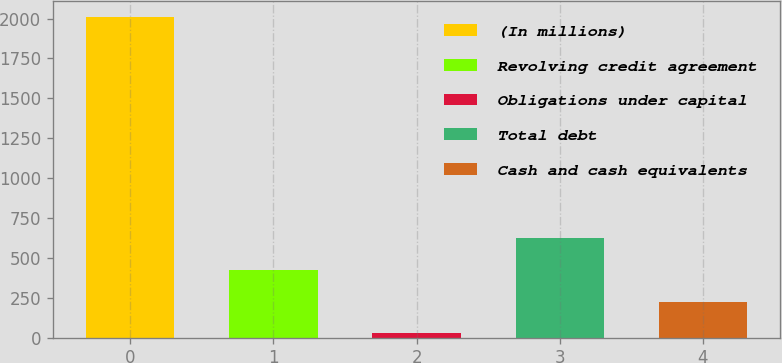<chart> <loc_0><loc_0><loc_500><loc_500><bar_chart><fcel>(In millions)<fcel>Revolving credit agreement<fcel>Obligations under capital<fcel>Total debt<fcel>Cash and cash equivalents<nl><fcel>2009<fcel>424.68<fcel>28.6<fcel>622.72<fcel>226.64<nl></chart> 